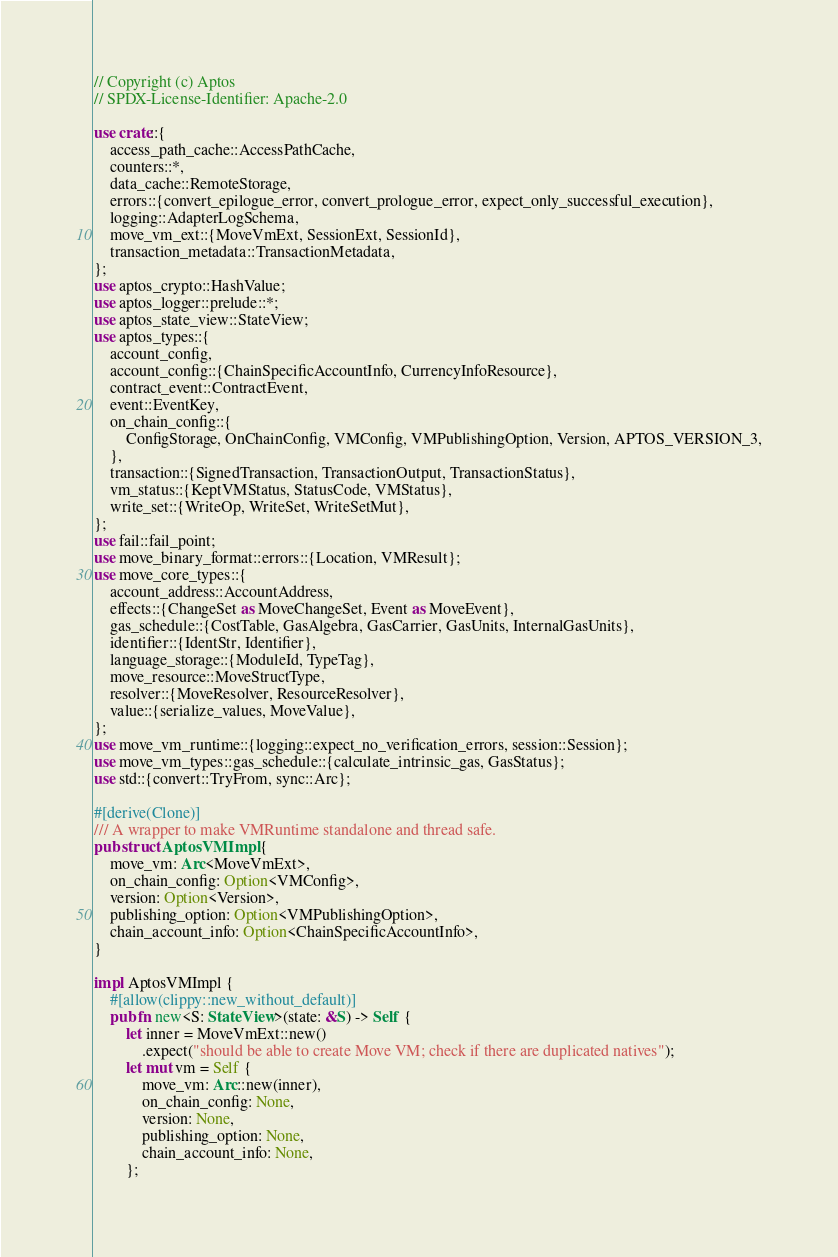Convert code to text. <code><loc_0><loc_0><loc_500><loc_500><_Rust_>// Copyright (c) Aptos
// SPDX-License-Identifier: Apache-2.0

use crate::{
    access_path_cache::AccessPathCache,
    counters::*,
    data_cache::RemoteStorage,
    errors::{convert_epilogue_error, convert_prologue_error, expect_only_successful_execution},
    logging::AdapterLogSchema,
    move_vm_ext::{MoveVmExt, SessionExt, SessionId},
    transaction_metadata::TransactionMetadata,
};
use aptos_crypto::HashValue;
use aptos_logger::prelude::*;
use aptos_state_view::StateView;
use aptos_types::{
    account_config,
    account_config::{ChainSpecificAccountInfo, CurrencyInfoResource},
    contract_event::ContractEvent,
    event::EventKey,
    on_chain_config::{
        ConfigStorage, OnChainConfig, VMConfig, VMPublishingOption, Version, APTOS_VERSION_3,
    },
    transaction::{SignedTransaction, TransactionOutput, TransactionStatus},
    vm_status::{KeptVMStatus, StatusCode, VMStatus},
    write_set::{WriteOp, WriteSet, WriteSetMut},
};
use fail::fail_point;
use move_binary_format::errors::{Location, VMResult};
use move_core_types::{
    account_address::AccountAddress,
    effects::{ChangeSet as MoveChangeSet, Event as MoveEvent},
    gas_schedule::{CostTable, GasAlgebra, GasCarrier, GasUnits, InternalGasUnits},
    identifier::{IdentStr, Identifier},
    language_storage::{ModuleId, TypeTag},
    move_resource::MoveStructType,
    resolver::{MoveResolver, ResourceResolver},
    value::{serialize_values, MoveValue},
};
use move_vm_runtime::{logging::expect_no_verification_errors, session::Session};
use move_vm_types::gas_schedule::{calculate_intrinsic_gas, GasStatus};
use std::{convert::TryFrom, sync::Arc};

#[derive(Clone)]
/// A wrapper to make VMRuntime standalone and thread safe.
pub struct AptosVMImpl {
    move_vm: Arc<MoveVmExt>,
    on_chain_config: Option<VMConfig>,
    version: Option<Version>,
    publishing_option: Option<VMPublishingOption>,
    chain_account_info: Option<ChainSpecificAccountInfo>,
}

impl AptosVMImpl {
    #[allow(clippy::new_without_default)]
    pub fn new<S: StateView>(state: &S) -> Self {
        let inner = MoveVmExt::new()
            .expect("should be able to create Move VM; check if there are duplicated natives");
        let mut vm = Self {
            move_vm: Arc::new(inner),
            on_chain_config: None,
            version: None,
            publishing_option: None,
            chain_account_info: None,
        };</code> 